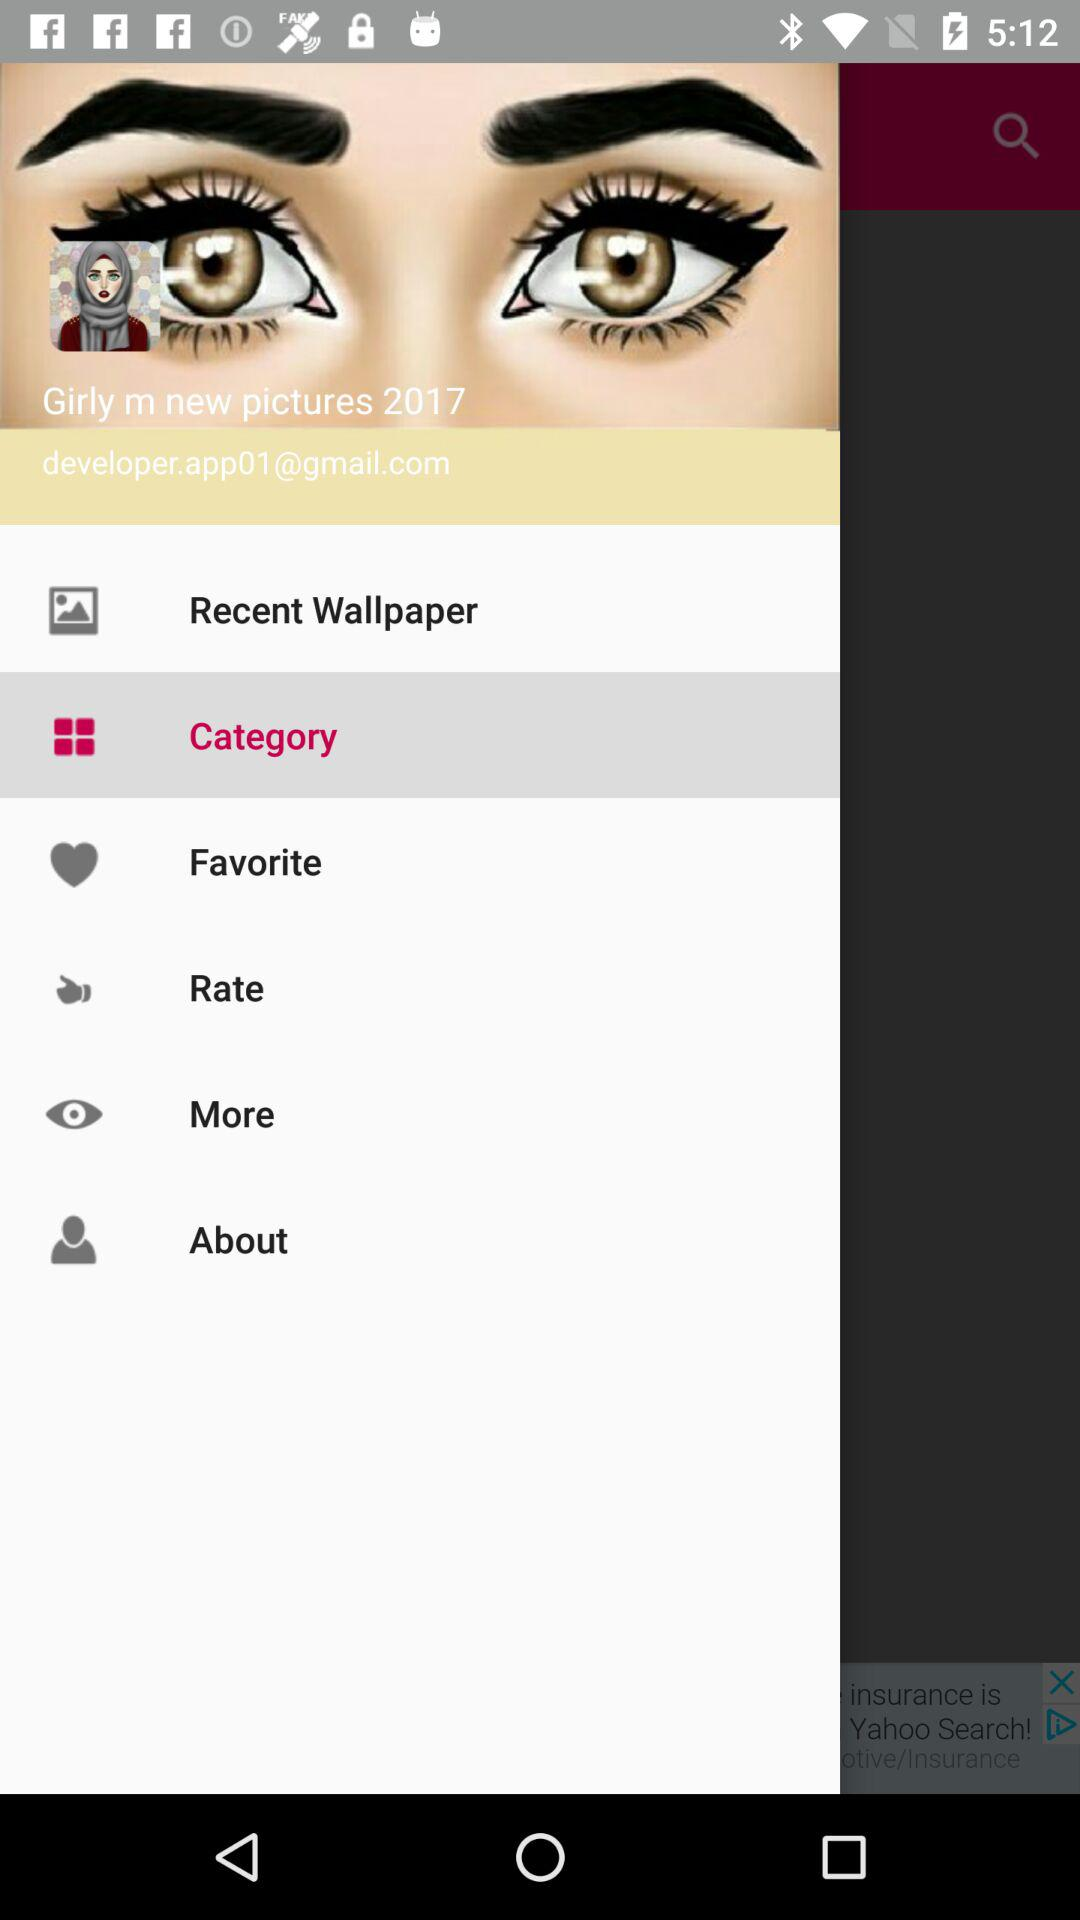Which item is selected in the menu? The selected item is "Category". 